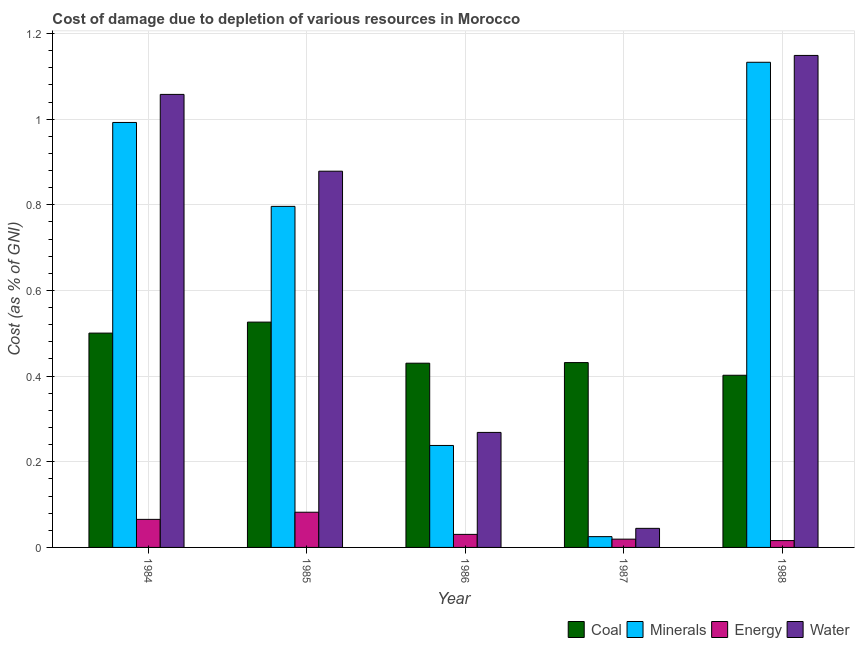How many different coloured bars are there?
Ensure brevity in your answer.  4. Are the number of bars per tick equal to the number of legend labels?
Make the answer very short. Yes. How many bars are there on the 4th tick from the left?
Your answer should be compact. 4. How many bars are there on the 1st tick from the right?
Your response must be concise. 4. What is the label of the 5th group of bars from the left?
Your response must be concise. 1988. What is the cost of damage due to depletion of coal in 1985?
Keep it short and to the point. 0.53. Across all years, what is the maximum cost of damage due to depletion of energy?
Your response must be concise. 0.08. Across all years, what is the minimum cost of damage due to depletion of coal?
Your answer should be very brief. 0.4. What is the total cost of damage due to depletion of water in the graph?
Give a very brief answer. 3.4. What is the difference between the cost of damage due to depletion of energy in 1986 and that in 1987?
Make the answer very short. 0.01. What is the difference between the cost of damage due to depletion of energy in 1988 and the cost of damage due to depletion of coal in 1984?
Give a very brief answer. -0.05. What is the average cost of damage due to depletion of coal per year?
Your answer should be very brief. 0.46. In the year 1988, what is the difference between the cost of damage due to depletion of energy and cost of damage due to depletion of coal?
Keep it short and to the point. 0. What is the ratio of the cost of damage due to depletion of coal in 1986 to that in 1987?
Your answer should be very brief. 1. Is the cost of damage due to depletion of energy in 1986 less than that in 1987?
Offer a very short reply. No. What is the difference between the highest and the second highest cost of damage due to depletion of energy?
Your answer should be very brief. 0.02. What is the difference between the highest and the lowest cost of damage due to depletion of minerals?
Your answer should be very brief. 1.11. In how many years, is the cost of damage due to depletion of water greater than the average cost of damage due to depletion of water taken over all years?
Provide a succinct answer. 3. Is it the case that in every year, the sum of the cost of damage due to depletion of coal and cost of damage due to depletion of water is greater than the sum of cost of damage due to depletion of energy and cost of damage due to depletion of minerals?
Provide a short and direct response. No. What does the 3rd bar from the left in 1986 represents?
Your response must be concise. Energy. What does the 1st bar from the right in 1985 represents?
Make the answer very short. Water. What is the difference between two consecutive major ticks on the Y-axis?
Ensure brevity in your answer.  0.2. Are the values on the major ticks of Y-axis written in scientific E-notation?
Ensure brevity in your answer.  No. What is the title of the graph?
Your answer should be compact. Cost of damage due to depletion of various resources in Morocco . Does "Taxes on revenue" appear as one of the legend labels in the graph?
Give a very brief answer. No. What is the label or title of the Y-axis?
Your answer should be very brief. Cost (as % of GNI). What is the Cost (as % of GNI) of Coal in 1984?
Give a very brief answer. 0.5. What is the Cost (as % of GNI) of Minerals in 1984?
Give a very brief answer. 0.99. What is the Cost (as % of GNI) of Energy in 1984?
Your answer should be very brief. 0.07. What is the Cost (as % of GNI) in Water in 1984?
Offer a very short reply. 1.06. What is the Cost (as % of GNI) in Coal in 1985?
Your response must be concise. 0.53. What is the Cost (as % of GNI) of Minerals in 1985?
Make the answer very short. 0.8. What is the Cost (as % of GNI) in Energy in 1985?
Ensure brevity in your answer.  0.08. What is the Cost (as % of GNI) of Water in 1985?
Provide a succinct answer. 0.88. What is the Cost (as % of GNI) of Coal in 1986?
Offer a terse response. 0.43. What is the Cost (as % of GNI) of Minerals in 1986?
Your answer should be compact. 0.24. What is the Cost (as % of GNI) of Energy in 1986?
Keep it short and to the point. 0.03. What is the Cost (as % of GNI) in Water in 1986?
Provide a short and direct response. 0.27. What is the Cost (as % of GNI) of Coal in 1987?
Offer a terse response. 0.43. What is the Cost (as % of GNI) of Minerals in 1987?
Provide a succinct answer. 0.03. What is the Cost (as % of GNI) of Energy in 1987?
Your answer should be compact. 0.02. What is the Cost (as % of GNI) of Water in 1987?
Your answer should be very brief. 0.04. What is the Cost (as % of GNI) of Coal in 1988?
Keep it short and to the point. 0.4. What is the Cost (as % of GNI) of Minerals in 1988?
Ensure brevity in your answer.  1.13. What is the Cost (as % of GNI) in Energy in 1988?
Your response must be concise. 0.02. What is the Cost (as % of GNI) of Water in 1988?
Keep it short and to the point. 1.15. Across all years, what is the maximum Cost (as % of GNI) of Coal?
Your response must be concise. 0.53. Across all years, what is the maximum Cost (as % of GNI) of Minerals?
Ensure brevity in your answer.  1.13. Across all years, what is the maximum Cost (as % of GNI) of Energy?
Provide a short and direct response. 0.08. Across all years, what is the maximum Cost (as % of GNI) in Water?
Offer a terse response. 1.15. Across all years, what is the minimum Cost (as % of GNI) of Coal?
Your answer should be very brief. 0.4. Across all years, what is the minimum Cost (as % of GNI) of Minerals?
Provide a short and direct response. 0.03. Across all years, what is the minimum Cost (as % of GNI) in Energy?
Give a very brief answer. 0.02. Across all years, what is the minimum Cost (as % of GNI) in Water?
Your answer should be very brief. 0.04. What is the total Cost (as % of GNI) of Coal in the graph?
Provide a succinct answer. 2.29. What is the total Cost (as % of GNI) in Minerals in the graph?
Your response must be concise. 3.18. What is the total Cost (as % of GNI) of Energy in the graph?
Make the answer very short. 0.21. What is the total Cost (as % of GNI) of Water in the graph?
Ensure brevity in your answer.  3.4. What is the difference between the Cost (as % of GNI) in Coal in 1984 and that in 1985?
Provide a short and direct response. -0.03. What is the difference between the Cost (as % of GNI) of Minerals in 1984 and that in 1985?
Ensure brevity in your answer.  0.2. What is the difference between the Cost (as % of GNI) in Energy in 1984 and that in 1985?
Your answer should be very brief. -0.02. What is the difference between the Cost (as % of GNI) in Water in 1984 and that in 1985?
Your answer should be very brief. 0.18. What is the difference between the Cost (as % of GNI) of Coal in 1984 and that in 1986?
Give a very brief answer. 0.07. What is the difference between the Cost (as % of GNI) of Minerals in 1984 and that in 1986?
Your response must be concise. 0.75. What is the difference between the Cost (as % of GNI) in Energy in 1984 and that in 1986?
Provide a succinct answer. 0.04. What is the difference between the Cost (as % of GNI) of Water in 1984 and that in 1986?
Make the answer very short. 0.79. What is the difference between the Cost (as % of GNI) of Coal in 1984 and that in 1987?
Make the answer very short. 0.07. What is the difference between the Cost (as % of GNI) of Minerals in 1984 and that in 1987?
Make the answer very short. 0.97. What is the difference between the Cost (as % of GNI) of Energy in 1984 and that in 1987?
Offer a terse response. 0.05. What is the difference between the Cost (as % of GNI) of Water in 1984 and that in 1987?
Offer a terse response. 1.01. What is the difference between the Cost (as % of GNI) of Coal in 1984 and that in 1988?
Offer a very short reply. 0.1. What is the difference between the Cost (as % of GNI) of Minerals in 1984 and that in 1988?
Offer a very short reply. -0.14. What is the difference between the Cost (as % of GNI) in Energy in 1984 and that in 1988?
Ensure brevity in your answer.  0.05. What is the difference between the Cost (as % of GNI) in Water in 1984 and that in 1988?
Provide a succinct answer. -0.09. What is the difference between the Cost (as % of GNI) in Coal in 1985 and that in 1986?
Keep it short and to the point. 0.1. What is the difference between the Cost (as % of GNI) in Minerals in 1985 and that in 1986?
Make the answer very short. 0.56. What is the difference between the Cost (as % of GNI) in Energy in 1985 and that in 1986?
Give a very brief answer. 0.05. What is the difference between the Cost (as % of GNI) in Water in 1985 and that in 1986?
Offer a terse response. 0.61. What is the difference between the Cost (as % of GNI) of Coal in 1985 and that in 1987?
Keep it short and to the point. 0.09. What is the difference between the Cost (as % of GNI) in Minerals in 1985 and that in 1987?
Offer a very short reply. 0.77. What is the difference between the Cost (as % of GNI) of Energy in 1985 and that in 1987?
Offer a very short reply. 0.06. What is the difference between the Cost (as % of GNI) of Water in 1985 and that in 1987?
Your answer should be compact. 0.83. What is the difference between the Cost (as % of GNI) of Coal in 1985 and that in 1988?
Provide a succinct answer. 0.12. What is the difference between the Cost (as % of GNI) in Minerals in 1985 and that in 1988?
Make the answer very short. -0.34. What is the difference between the Cost (as % of GNI) of Energy in 1985 and that in 1988?
Your answer should be very brief. 0.07. What is the difference between the Cost (as % of GNI) of Water in 1985 and that in 1988?
Ensure brevity in your answer.  -0.27. What is the difference between the Cost (as % of GNI) in Coal in 1986 and that in 1987?
Make the answer very short. -0. What is the difference between the Cost (as % of GNI) in Minerals in 1986 and that in 1987?
Provide a short and direct response. 0.21. What is the difference between the Cost (as % of GNI) of Energy in 1986 and that in 1987?
Make the answer very short. 0.01. What is the difference between the Cost (as % of GNI) in Water in 1986 and that in 1987?
Ensure brevity in your answer.  0.22. What is the difference between the Cost (as % of GNI) of Coal in 1986 and that in 1988?
Your answer should be very brief. 0.03. What is the difference between the Cost (as % of GNI) of Minerals in 1986 and that in 1988?
Your answer should be very brief. -0.89. What is the difference between the Cost (as % of GNI) in Energy in 1986 and that in 1988?
Provide a short and direct response. 0.01. What is the difference between the Cost (as % of GNI) in Water in 1986 and that in 1988?
Your answer should be very brief. -0.88. What is the difference between the Cost (as % of GNI) of Coal in 1987 and that in 1988?
Offer a very short reply. 0.03. What is the difference between the Cost (as % of GNI) of Minerals in 1987 and that in 1988?
Your response must be concise. -1.11. What is the difference between the Cost (as % of GNI) of Energy in 1987 and that in 1988?
Your answer should be compact. 0. What is the difference between the Cost (as % of GNI) of Water in 1987 and that in 1988?
Make the answer very short. -1.1. What is the difference between the Cost (as % of GNI) in Coal in 1984 and the Cost (as % of GNI) in Minerals in 1985?
Offer a very short reply. -0.3. What is the difference between the Cost (as % of GNI) of Coal in 1984 and the Cost (as % of GNI) of Energy in 1985?
Your answer should be very brief. 0.42. What is the difference between the Cost (as % of GNI) in Coal in 1984 and the Cost (as % of GNI) in Water in 1985?
Offer a very short reply. -0.38. What is the difference between the Cost (as % of GNI) in Minerals in 1984 and the Cost (as % of GNI) in Energy in 1985?
Offer a terse response. 0.91. What is the difference between the Cost (as % of GNI) of Minerals in 1984 and the Cost (as % of GNI) of Water in 1985?
Keep it short and to the point. 0.11. What is the difference between the Cost (as % of GNI) of Energy in 1984 and the Cost (as % of GNI) of Water in 1985?
Your answer should be very brief. -0.81. What is the difference between the Cost (as % of GNI) of Coal in 1984 and the Cost (as % of GNI) of Minerals in 1986?
Offer a very short reply. 0.26. What is the difference between the Cost (as % of GNI) in Coal in 1984 and the Cost (as % of GNI) in Energy in 1986?
Your response must be concise. 0.47. What is the difference between the Cost (as % of GNI) in Coal in 1984 and the Cost (as % of GNI) in Water in 1986?
Your response must be concise. 0.23. What is the difference between the Cost (as % of GNI) in Minerals in 1984 and the Cost (as % of GNI) in Energy in 1986?
Offer a terse response. 0.96. What is the difference between the Cost (as % of GNI) of Minerals in 1984 and the Cost (as % of GNI) of Water in 1986?
Offer a very short reply. 0.72. What is the difference between the Cost (as % of GNI) of Energy in 1984 and the Cost (as % of GNI) of Water in 1986?
Provide a short and direct response. -0.2. What is the difference between the Cost (as % of GNI) of Coal in 1984 and the Cost (as % of GNI) of Minerals in 1987?
Provide a succinct answer. 0.48. What is the difference between the Cost (as % of GNI) of Coal in 1984 and the Cost (as % of GNI) of Energy in 1987?
Provide a short and direct response. 0.48. What is the difference between the Cost (as % of GNI) in Coal in 1984 and the Cost (as % of GNI) in Water in 1987?
Your response must be concise. 0.46. What is the difference between the Cost (as % of GNI) in Minerals in 1984 and the Cost (as % of GNI) in Water in 1987?
Give a very brief answer. 0.95. What is the difference between the Cost (as % of GNI) in Energy in 1984 and the Cost (as % of GNI) in Water in 1987?
Offer a very short reply. 0.02. What is the difference between the Cost (as % of GNI) of Coal in 1984 and the Cost (as % of GNI) of Minerals in 1988?
Provide a succinct answer. -0.63. What is the difference between the Cost (as % of GNI) in Coal in 1984 and the Cost (as % of GNI) in Energy in 1988?
Provide a short and direct response. 0.48. What is the difference between the Cost (as % of GNI) of Coal in 1984 and the Cost (as % of GNI) of Water in 1988?
Provide a succinct answer. -0.65. What is the difference between the Cost (as % of GNI) of Minerals in 1984 and the Cost (as % of GNI) of Energy in 1988?
Your answer should be very brief. 0.98. What is the difference between the Cost (as % of GNI) of Minerals in 1984 and the Cost (as % of GNI) of Water in 1988?
Ensure brevity in your answer.  -0.16. What is the difference between the Cost (as % of GNI) of Energy in 1984 and the Cost (as % of GNI) of Water in 1988?
Provide a short and direct response. -1.08. What is the difference between the Cost (as % of GNI) in Coal in 1985 and the Cost (as % of GNI) in Minerals in 1986?
Your answer should be very brief. 0.29. What is the difference between the Cost (as % of GNI) in Coal in 1985 and the Cost (as % of GNI) in Energy in 1986?
Keep it short and to the point. 0.5. What is the difference between the Cost (as % of GNI) of Coal in 1985 and the Cost (as % of GNI) of Water in 1986?
Give a very brief answer. 0.26. What is the difference between the Cost (as % of GNI) of Minerals in 1985 and the Cost (as % of GNI) of Energy in 1986?
Keep it short and to the point. 0.77. What is the difference between the Cost (as % of GNI) of Minerals in 1985 and the Cost (as % of GNI) of Water in 1986?
Ensure brevity in your answer.  0.53. What is the difference between the Cost (as % of GNI) of Energy in 1985 and the Cost (as % of GNI) of Water in 1986?
Provide a short and direct response. -0.19. What is the difference between the Cost (as % of GNI) of Coal in 1985 and the Cost (as % of GNI) of Minerals in 1987?
Offer a terse response. 0.5. What is the difference between the Cost (as % of GNI) of Coal in 1985 and the Cost (as % of GNI) of Energy in 1987?
Make the answer very short. 0.51. What is the difference between the Cost (as % of GNI) in Coal in 1985 and the Cost (as % of GNI) in Water in 1987?
Give a very brief answer. 0.48. What is the difference between the Cost (as % of GNI) in Minerals in 1985 and the Cost (as % of GNI) in Energy in 1987?
Ensure brevity in your answer.  0.78. What is the difference between the Cost (as % of GNI) of Minerals in 1985 and the Cost (as % of GNI) of Water in 1987?
Your answer should be compact. 0.75. What is the difference between the Cost (as % of GNI) of Energy in 1985 and the Cost (as % of GNI) of Water in 1987?
Your response must be concise. 0.04. What is the difference between the Cost (as % of GNI) of Coal in 1985 and the Cost (as % of GNI) of Minerals in 1988?
Make the answer very short. -0.61. What is the difference between the Cost (as % of GNI) of Coal in 1985 and the Cost (as % of GNI) of Energy in 1988?
Provide a short and direct response. 0.51. What is the difference between the Cost (as % of GNI) in Coal in 1985 and the Cost (as % of GNI) in Water in 1988?
Your answer should be compact. -0.62. What is the difference between the Cost (as % of GNI) in Minerals in 1985 and the Cost (as % of GNI) in Energy in 1988?
Offer a terse response. 0.78. What is the difference between the Cost (as % of GNI) of Minerals in 1985 and the Cost (as % of GNI) of Water in 1988?
Offer a terse response. -0.35. What is the difference between the Cost (as % of GNI) in Energy in 1985 and the Cost (as % of GNI) in Water in 1988?
Your answer should be compact. -1.07. What is the difference between the Cost (as % of GNI) of Coal in 1986 and the Cost (as % of GNI) of Minerals in 1987?
Give a very brief answer. 0.41. What is the difference between the Cost (as % of GNI) of Coal in 1986 and the Cost (as % of GNI) of Energy in 1987?
Provide a succinct answer. 0.41. What is the difference between the Cost (as % of GNI) in Coal in 1986 and the Cost (as % of GNI) in Water in 1987?
Offer a terse response. 0.39. What is the difference between the Cost (as % of GNI) in Minerals in 1986 and the Cost (as % of GNI) in Energy in 1987?
Offer a very short reply. 0.22. What is the difference between the Cost (as % of GNI) of Minerals in 1986 and the Cost (as % of GNI) of Water in 1987?
Offer a very short reply. 0.19. What is the difference between the Cost (as % of GNI) in Energy in 1986 and the Cost (as % of GNI) in Water in 1987?
Your answer should be compact. -0.01. What is the difference between the Cost (as % of GNI) in Coal in 1986 and the Cost (as % of GNI) in Minerals in 1988?
Your response must be concise. -0.7. What is the difference between the Cost (as % of GNI) in Coal in 1986 and the Cost (as % of GNI) in Energy in 1988?
Your response must be concise. 0.41. What is the difference between the Cost (as % of GNI) of Coal in 1986 and the Cost (as % of GNI) of Water in 1988?
Offer a very short reply. -0.72. What is the difference between the Cost (as % of GNI) in Minerals in 1986 and the Cost (as % of GNI) in Energy in 1988?
Make the answer very short. 0.22. What is the difference between the Cost (as % of GNI) of Minerals in 1986 and the Cost (as % of GNI) of Water in 1988?
Ensure brevity in your answer.  -0.91. What is the difference between the Cost (as % of GNI) in Energy in 1986 and the Cost (as % of GNI) in Water in 1988?
Your answer should be very brief. -1.12. What is the difference between the Cost (as % of GNI) of Coal in 1987 and the Cost (as % of GNI) of Minerals in 1988?
Your response must be concise. -0.7. What is the difference between the Cost (as % of GNI) of Coal in 1987 and the Cost (as % of GNI) of Energy in 1988?
Ensure brevity in your answer.  0.42. What is the difference between the Cost (as % of GNI) in Coal in 1987 and the Cost (as % of GNI) in Water in 1988?
Provide a short and direct response. -0.72. What is the difference between the Cost (as % of GNI) of Minerals in 1987 and the Cost (as % of GNI) of Energy in 1988?
Provide a short and direct response. 0.01. What is the difference between the Cost (as % of GNI) of Minerals in 1987 and the Cost (as % of GNI) of Water in 1988?
Keep it short and to the point. -1.12. What is the difference between the Cost (as % of GNI) of Energy in 1987 and the Cost (as % of GNI) of Water in 1988?
Ensure brevity in your answer.  -1.13. What is the average Cost (as % of GNI) of Coal per year?
Give a very brief answer. 0.46. What is the average Cost (as % of GNI) in Minerals per year?
Give a very brief answer. 0.64. What is the average Cost (as % of GNI) of Energy per year?
Ensure brevity in your answer.  0.04. What is the average Cost (as % of GNI) of Water per year?
Offer a very short reply. 0.68. In the year 1984, what is the difference between the Cost (as % of GNI) in Coal and Cost (as % of GNI) in Minerals?
Offer a terse response. -0.49. In the year 1984, what is the difference between the Cost (as % of GNI) in Coal and Cost (as % of GNI) in Energy?
Ensure brevity in your answer.  0.43. In the year 1984, what is the difference between the Cost (as % of GNI) of Coal and Cost (as % of GNI) of Water?
Your answer should be compact. -0.56. In the year 1984, what is the difference between the Cost (as % of GNI) in Minerals and Cost (as % of GNI) in Energy?
Keep it short and to the point. 0.93. In the year 1984, what is the difference between the Cost (as % of GNI) of Minerals and Cost (as % of GNI) of Water?
Make the answer very short. -0.07. In the year 1984, what is the difference between the Cost (as % of GNI) in Energy and Cost (as % of GNI) in Water?
Offer a very short reply. -0.99. In the year 1985, what is the difference between the Cost (as % of GNI) in Coal and Cost (as % of GNI) in Minerals?
Ensure brevity in your answer.  -0.27. In the year 1985, what is the difference between the Cost (as % of GNI) of Coal and Cost (as % of GNI) of Energy?
Keep it short and to the point. 0.44. In the year 1985, what is the difference between the Cost (as % of GNI) in Coal and Cost (as % of GNI) in Water?
Provide a succinct answer. -0.35. In the year 1985, what is the difference between the Cost (as % of GNI) in Minerals and Cost (as % of GNI) in Energy?
Make the answer very short. 0.71. In the year 1985, what is the difference between the Cost (as % of GNI) in Minerals and Cost (as % of GNI) in Water?
Your answer should be very brief. -0.08. In the year 1985, what is the difference between the Cost (as % of GNI) of Energy and Cost (as % of GNI) of Water?
Make the answer very short. -0.8. In the year 1986, what is the difference between the Cost (as % of GNI) of Coal and Cost (as % of GNI) of Minerals?
Make the answer very short. 0.19. In the year 1986, what is the difference between the Cost (as % of GNI) in Coal and Cost (as % of GNI) in Energy?
Keep it short and to the point. 0.4. In the year 1986, what is the difference between the Cost (as % of GNI) in Coal and Cost (as % of GNI) in Water?
Make the answer very short. 0.16. In the year 1986, what is the difference between the Cost (as % of GNI) of Minerals and Cost (as % of GNI) of Energy?
Your response must be concise. 0.21. In the year 1986, what is the difference between the Cost (as % of GNI) of Minerals and Cost (as % of GNI) of Water?
Offer a very short reply. -0.03. In the year 1986, what is the difference between the Cost (as % of GNI) of Energy and Cost (as % of GNI) of Water?
Provide a succinct answer. -0.24. In the year 1987, what is the difference between the Cost (as % of GNI) in Coal and Cost (as % of GNI) in Minerals?
Provide a succinct answer. 0.41. In the year 1987, what is the difference between the Cost (as % of GNI) in Coal and Cost (as % of GNI) in Energy?
Offer a very short reply. 0.41. In the year 1987, what is the difference between the Cost (as % of GNI) in Coal and Cost (as % of GNI) in Water?
Your answer should be compact. 0.39. In the year 1987, what is the difference between the Cost (as % of GNI) of Minerals and Cost (as % of GNI) of Energy?
Keep it short and to the point. 0.01. In the year 1987, what is the difference between the Cost (as % of GNI) of Minerals and Cost (as % of GNI) of Water?
Provide a short and direct response. -0.02. In the year 1987, what is the difference between the Cost (as % of GNI) of Energy and Cost (as % of GNI) of Water?
Ensure brevity in your answer.  -0.03. In the year 1988, what is the difference between the Cost (as % of GNI) in Coal and Cost (as % of GNI) in Minerals?
Provide a short and direct response. -0.73. In the year 1988, what is the difference between the Cost (as % of GNI) in Coal and Cost (as % of GNI) in Energy?
Provide a short and direct response. 0.39. In the year 1988, what is the difference between the Cost (as % of GNI) in Coal and Cost (as % of GNI) in Water?
Offer a very short reply. -0.75. In the year 1988, what is the difference between the Cost (as % of GNI) of Minerals and Cost (as % of GNI) of Energy?
Provide a succinct answer. 1.12. In the year 1988, what is the difference between the Cost (as % of GNI) in Minerals and Cost (as % of GNI) in Water?
Give a very brief answer. -0.02. In the year 1988, what is the difference between the Cost (as % of GNI) in Energy and Cost (as % of GNI) in Water?
Offer a terse response. -1.13. What is the ratio of the Cost (as % of GNI) in Coal in 1984 to that in 1985?
Offer a very short reply. 0.95. What is the ratio of the Cost (as % of GNI) in Minerals in 1984 to that in 1985?
Your answer should be compact. 1.25. What is the ratio of the Cost (as % of GNI) in Energy in 1984 to that in 1985?
Make the answer very short. 0.8. What is the ratio of the Cost (as % of GNI) of Water in 1984 to that in 1985?
Provide a short and direct response. 1.2. What is the ratio of the Cost (as % of GNI) of Coal in 1984 to that in 1986?
Offer a terse response. 1.16. What is the ratio of the Cost (as % of GNI) of Minerals in 1984 to that in 1986?
Offer a very short reply. 4.17. What is the ratio of the Cost (as % of GNI) of Energy in 1984 to that in 1986?
Provide a succinct answer. 2.15. What is the ratio of the Cost (as % of GNI) of Water in 1984 to that in 1986?
Offer a terse response. 3.94. What is the ratio of the Cost (as % of GNI) in Coal in 1984 to that in 1987?
Offer a very short reply. 1.16. What is the ratio of the Cost (as % of GNI) of Minerals in 1984 to that in 1987?
Offer a terse response. 39.35. What is the ratio of the Cost (as % of GNI) of Energy in 1984 to that in 1987?
Ensure brevity in your answer.  3.39. What is the ratio of the Cost (as % of GNI) in Water in 1984 to that in 1987?
Offer a very short reply. 23.75. What is the ratio of the Cost (as % of GNI) in Coal in 1984 to that in 1988?
Keep it short and to the point. 1.24. What is the ratio of the Cost (as % of GNI) in Minerals in 1984 to that in 1988?
Provide a succinct answer. 0.88. What is the ratio of the Cost (as % of GNI) of Energy in 1984 to that in 1988?
Your response must be concise. 4.1. What is the ratio of the Cost (as % of GNI) of Water in 1984 to that in 1988?
Provide a succinct answer. 0.92. What is the ratio of the Cost (as % of GNI) in Coal in 1985 to that in 1986?
Offer a very short reply. 1.22. What is the ratio of the Cost (as % of GNI) of Minerals in 1985 to that in 1986?
Your response must be concise. 3.34. What is the ratio of the Cost (as % of GNI) of Energy in 1985 to that in 1986?
Your answer should be very brief. 2.7. What is the ratio of the Cost (as % of GNI) of Water in 1985 to that in 1986?
Ensure brevity in your answer.  3.27. What is the ratio of the Cost (as % of GNI) in Coal in 1985 to that in 1987?
Provide a succinct answer. 1.22. What is the ratio of the Cost (as % of GNI) in Minerals in 1985 to that in 1987?
Your answer should be compact. 31.58. What is the ratio of the Cost (as % of GNI) in Energy in 1985 to that in 1987?
Your response must be concise. 4.25. What is the ratio of the Cost (as % of GNI) of Water in 1985 to that in 1987?
Provide a succinct answer. 19.73. What is the ratio of the Cost (as % of GNI) of Coal in 1985 to that in 1988?
Ensure brevity in your answer.  1.31. What is the ratio of the Cost (as % of GNI) in Minerals in 1985 to that in 1988?
Your answer should be compact. 0.7. What is the ratio of the Cost (as % of GNI) in Energy in 1985 to that in 1988?
Ensure brevity in your answer.  5.14. What is the ratio of the Cost (as % of GNI) in Water in 1985 to that in 1988?
Provide a short and direct response. 0.76. What is the ratio of the Cost (as % of GNI) in Minerals in 1986 to that in 1987?
Make the answer very short. 9.44. What is the ratio of the Cost (as % of GNI) of Energy in 1986 to that in 1987?
Ensure brevity in your answer.  1.58. What is the ratio of the Cost (as % of GNI) in Water in 1986 to that in 1987?
Provide a succinct answer. 6.03. What is the ratio of the Cost (as % of GNI) in Coal in 1986 to that in 1988?
Provide a short and direct response. 1.07. What is the ratio of the Cost (as % of GNI) in Minerals in 1986 to that in 1988?
Make the answer very short. 0.21. What is the ratio of the Cost (as % of GNI) in Energy in 1986 to that in 1988?
Your answer should be very brief. 1.9. What is the ratio of the Cost (as % of GNI) in Water in 1986 to that in 1988?
Ensure brevity in your answer.  0.23. What is the ratio of the Cost (as % of GNI) of Coal in 1987 to that in 1988?
Provide a succinct answer. 1.07. What is the ratio of the Cost (as % of GNI) in Minerals in 1987 to that in 1988?
Ensure brevity in your answer.  0.02. What is the ratio of the Cost (as % of GNI) in Energy in 1987 to that in 1988?
Your response must be concise. 1.21. What is the ratio of the Cost (as % of GNI) of Water in 1987 to that in 1988?
Make the answer very short. 0.04. What is the difference between the highest and the second highest Cost (as % of GNI) in Coal?
Offer a very short reply. 0.03. What is the difference between the highest and the second highest Cost (as % of GNI) of Minerals?
Ensure brevity in your answer.  0.14. What is the difference between the highest and the second highest Cost (as % of GNI) in Energy?
Provide a short and direct response. 0.02. What is the difference between the highest and the second highest Cost (as % of GNI) in Water?
Keep it short and to the point. 0.09. What is the difference between the highest and the lowest Cost (as % of GNI) in Coal?
Offer a very short reply. 0.12. What is the difference between the highest and the lowest Cost (as % of GNI) of Minerals?
Keep it short and to the point. 1.11. What is the difference between the highest and the lowest Cost (as % of GNI) of Energy?
Give a very brief answer. 0.07. What is the difference between the highest and the lowest Cost (as % of GNI) in Water?
Your answer should be very brief. 1.1. 